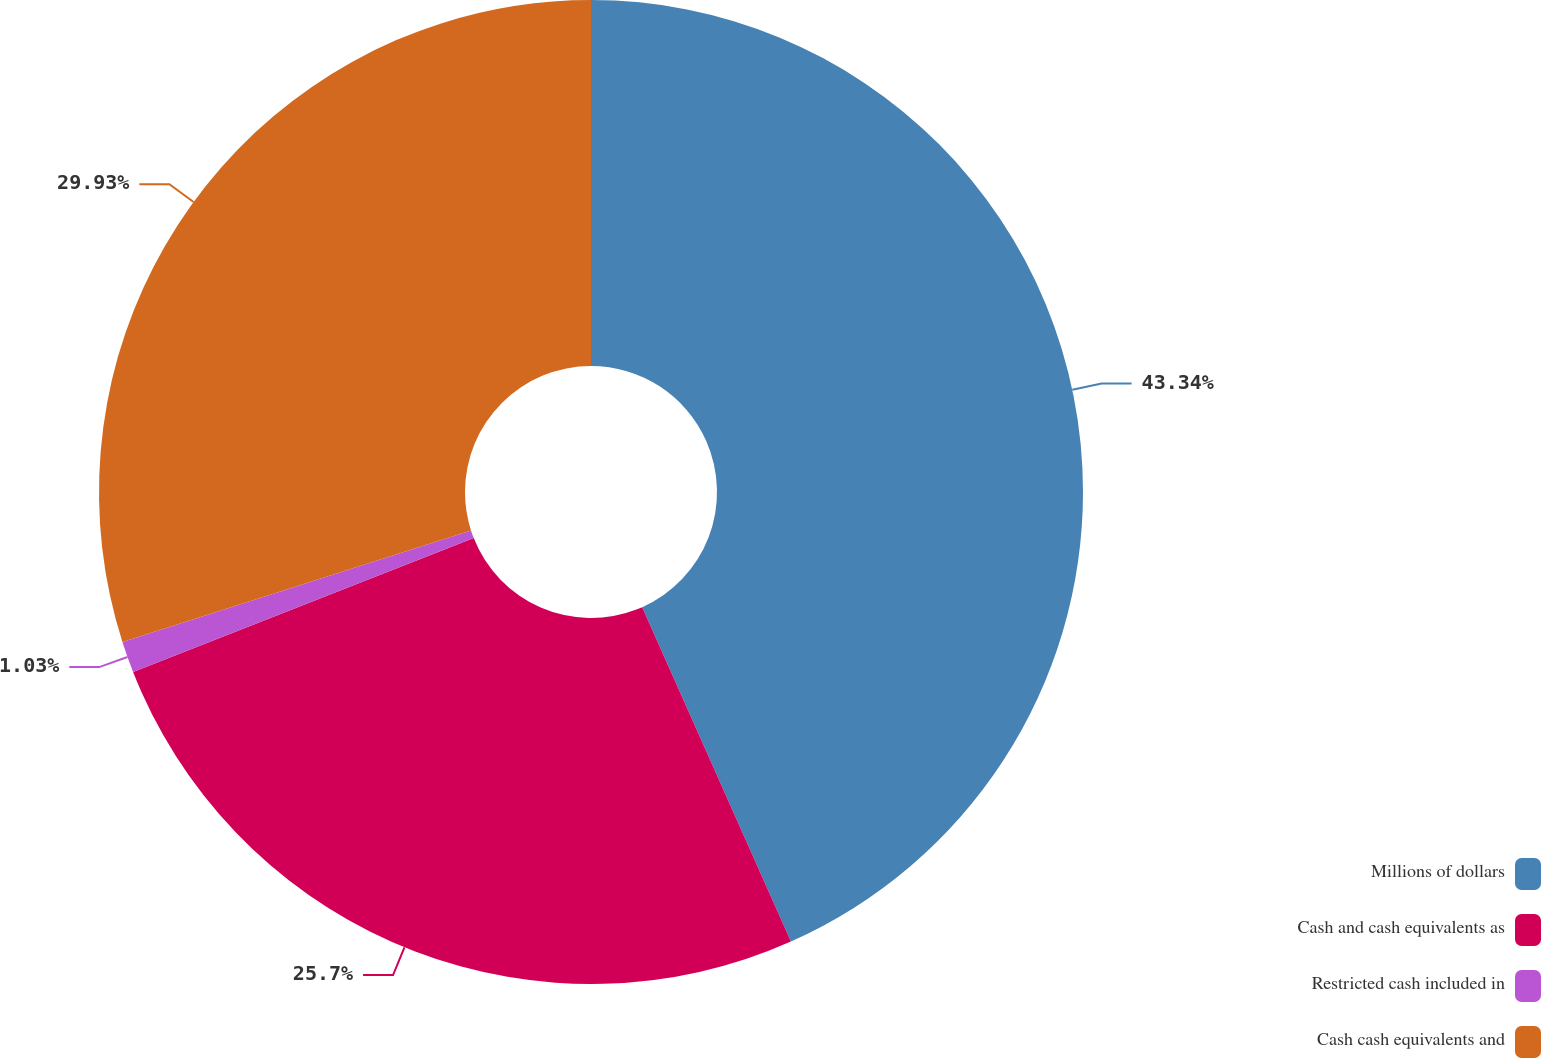Convert chart. <chart><loc_0><loc_0><loc_500><loc_500><pie_chart><fcel>Millions of dollars<fcel>Cash and cash equivalents as<fcel>Restricted cash included in<fcel>Cash cash equivalents and<nl><fcel>43.34%<fcel>25.7%<fcel>1.03%<fcel>29.93%<nl></chart> 